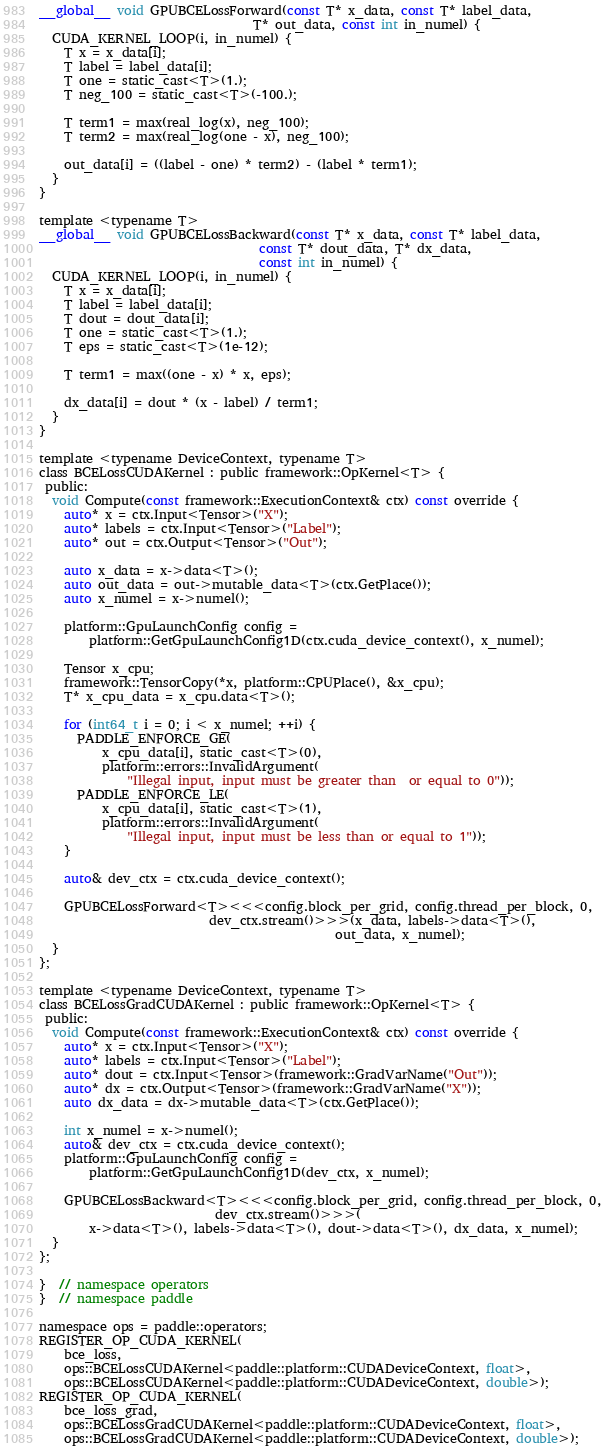Convert code to text. <code><loc_0><loc_0><loc_500><loc_500><_Cuda_>__global__ void GPUBCELossForward(const T* x_data, const T* label_data,
                                  T* out_data, const int in_numel) {
  CUDA_KERNEL_LOOP(i, in_numel) {
    T x = x_data[i];
    T label = label_data[i];
    T one = static_cast<T>(1.);
    T neg_100 = static_cast<T>(-100.);

    T term1 = max(real_log(x), neg_100);
    T term2 = max(real_log(one - x), neg_100);

    out_data[i] = ((label - one) * term2) - (label * term1);
  }
}

template <typename T>
__global__ void GPUBCELossBackward(const T* x_data, const T* label_data,
                                   const T* dout_data, T* dx_data,
                                   const int in_numel) {
  CUDA_KERNEL_LOOP(i, in_numel) {
    T x = x_data[i];
    T label = label_data[i];
    T dout = dout_data[i];
    T one = static_cast<T>(1.);
    T eps = static_cast<T>(1e-12);

    T term1 = max((one - x) * x, eps);

    dx_data[i] = dout * (x - label) / term1;
  }
}

template <typename DeviceContext, typename T>
class BCELossCUDAKernel : public framework::OpKernel<T> {
 public:
  void Compute(const framework::ExecutionContext& ctx) const override {
    auto* x = ctx.Input<Tensor>("X");
    auto* labels = ctx.Input<Tensor>("Label");
    auto* out = ctx.Output<Tensor>("Out");

    auto x_data = x->data<T>();
    auto out_data = out->mutable_data<T>(ctx.GetPlace());
    auto x_numel = x->numel();

    platform::GpuLaunchConfig config =
        platform::GetGpuLaunchConfig1D(ctx.cuda_device_context(), x_numel);

    Tensor x_cpu;
    framework::TensorCopy(*x, platform::CPUPlace(), &x_cpu);
    T* x_cpu_data = x_cpu.data<T>();

    for (int64_t i = 0; i < x_numel; ++i) {
      PADDLE_ENFORCE_GE(
          x_cpu_data[i], static_cast<T>(0),
          platform::errors::InvalidArgument(
              "Illegal input, input must be greater than  or equal to 0"));
      PADDLE_ENFORCE_LE(
          x_cpu_data[i], static_cast<T>(1),
          platform::errors::InvalidArgument(
              "Illegal input, input must be less than or equal to 1"));
    }

    auto& dev_ctx = ctx.cuda_device_context();

    GPUBCELossForward<T><<<config.block_per_grid, config.thread_per_block, 0,
                           dev_ctx.stream()>>>(x_data, labels->data<T>(),
                                               out_data, x_numel);
  }
};

template <typename DeviceContext, typename T>
class BCELossGradCUDAKernel : public framework::OpKernel<T> {
 public:
  void Compute(const framework::ExecutionContext& ctx) const override {
    auto* x = ctx.Input<Tensor>("X");
    auto* labels = ctx.Input<Tensor>("Label");
    auto* dout = ctx.Input<Tensor>(framework::GradVarName("Out"));
    auto* dx = ctx.Output<Tensor>(framework::GradVarName("X"));
    auto dx_data = dx->mutable_data<T>(ctx.GetPlace());

    int x_numel = x->numel();
    auto& dev_ctx = ctx.cuda_device_context();
    platform::GpuLaunchConfig config =
        platform::GetGpuLaunchConfig1D(dev_ctx, x_numel);

    GPUBCELossBackward<T><<<config.block_per_grid, config.thread_per_block, 0,
                            dev_ctx.stream()>>>(
        x->data<T>(), labels->data<T>(), dout->data<T>(), dx_data, x_numel);
  }
};

}  // namespace operators
}  // namespace paddle

namespace ops = paddle::operators;
REGISTER_OP_CUDA_KERNEL(
    bce_loss,
    ops::BCELossCUDAKernel<paddle::platform::CUDADeviceContext, float>,
    ops::BCELossCUDAKernel<paddle::platform::CUDADeviceContext, double>);
REGISTER_OP_CUDA_KERNEL(
    bce_loss_grad,
    ops::BCELossGradCUDAKernel<paddle::platform::CUDADeviceContext, float>,
    ops::BCELossGradCUDAKernel<paddle::platform::CUDADeviceContext, double>);
</code> 